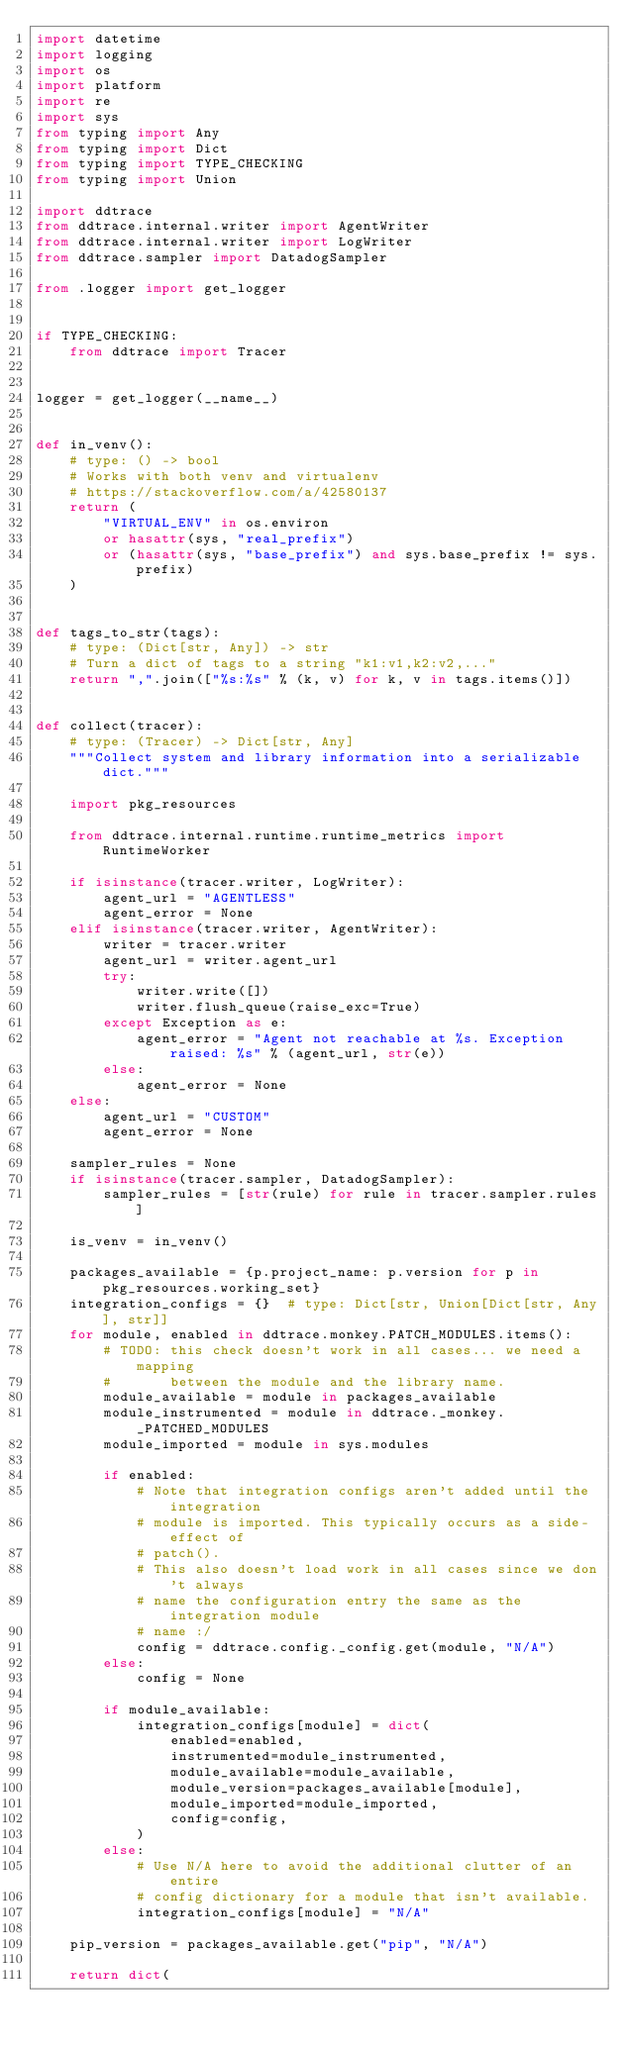<code> <loc_0><loc_0><loc_500><loc_500><_Python_>import datetime
import logging
import os
import platform
import re
import sys
from typing import Any
from typing import Dict
from typing import TYPE_CHECKING
from typing import Union

import ddtrace
from ddtrace.internal.writer import AgentWriter
from ddtrace.internal.writer import LogWriter
from ddtrace.sampler import DatadogSampler

from .logger import get_logger


if TYPE_CHECKING:
    from ddtrace import Tracer


logger = get_logger(__name__)


def in_venv():
    # type: () -> bool
    # Works with both venv and virtualenv
    # https://stackoverflow.com/a/42580137
    return (
        "VIRTUAL_ENV" in os.environ
        or hasattr(sys, "real_prefix")
        or (hasattr(sys, "base_prefix") and sys.base_prefix != sys.prefix)
    )


def tags_to_str(tags):
    # type: (Dict[str, Any]) -> str
    # Turn a dict of tags to a string "k1:v1,k2:v2,..."
    return ",".join(["%s:%s" % (k, v) for k, v in tags.items()])


def collect(tracer):
    # type: (Tracer) -> Dict[str, Any]
    """Collect system and library information into a serializable dict."""

    import pkg_resources

    from ddtrace.internal.runtime.runtime_metrics import RuntimeWorker

    if isinstance(tracer.writer, LogWriter):
        agent_url = "AGENTLESS"
        agent_error = None
    elif isinstance(tracer.writer, AgentWriter):
        writer = tracer.writer
        agent_url = writer.agent_url
        try:
            writer.write([])
            writer.flush_queue(raise_exc=True)
        except Exception as e:
            agent_error = "Agent not reachable at %s. Exception raised: %s" % (agent_url, str(e))
        else:
            agent_error = None
    else:
        agent_url = "CUSTOM"
        agent_error = None

    sampler_rules = None
    if isinstance(tracer.sampler, DatadogSampler):
        sampler_rules = [str(rule) for rule in tracer.sampler.rules]

    is_venv = in_venv()

    packages_available = {p.project_name: p.version for p in pkg_resources.working_set}
    integration_configs = {}  # type: Dict[str, Union[Dict[str, Any], str]]
    for module, enabled in ddtrace.monkey.PATCH_MODULES.items():
        # TODO: this check doesn't work in all cases... we need a mapping
        #       between the module and the library name.
        module_available = module in packages_available
        module_instrumented = module in ddtrace._monkey._PATCHED_MODULES
        module_imported = module in sys.modules

        if enabled:
            # Note that integration configs aren't added until the integration
            # module is imported. This typically occurs as a side-effect of
            # patch().
            # This also doesn't load work in all cases since we don't always
            # name the configuration entry the same as the integration module
            # name :/
            config = ddtrace.config._config.get(module, "N/A")
        else:
            config = None

        if module_available:
            integration_configs[module] = dict(
                enabled=enabled,
                instrumented=module_instrumented,
                module_available=module_available,
                module_version=packages_available[module],
                module_imported=module_imported,
                config=config,
            )
        else:
            # Use N/A here to avoid the additional clutter of an entire
            # config dictionary for a module that isn't available.
            integration_configs[module] = "N/A"

    pip_version = packages_available.get("pip", "N/A")

    return dict(</code> 